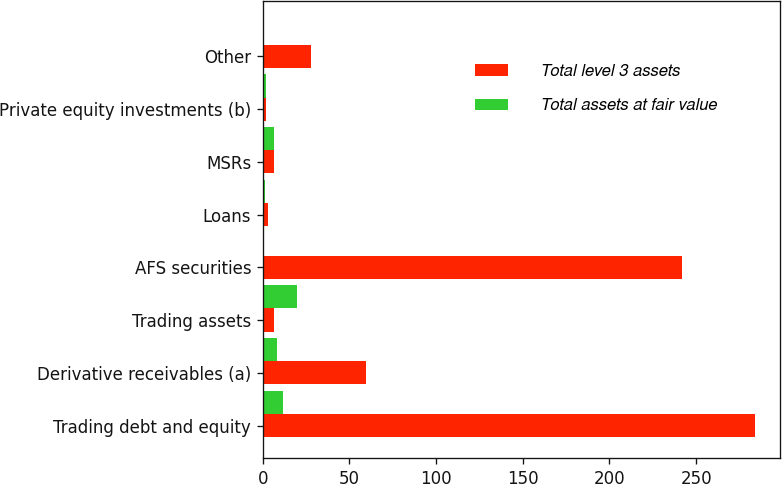<chart> <loc_0><loc_0><loc_500><loc_500><stacked_bar_chart><ecel><fcel>Trading debt and equity<fcel>Derivative receivables (a)<fcel>Trading assets<fcel>AFS securities<fcel>Loans<fcel>MSRs<fcel>Private equity investments (b)<fcel>Other<nl><fcel>Total level 3 assets<fcel>284.1<fcel>59.7<fcel>6.6<fcel>241.8<fcel>2.9<fcel>6.6<fcel>1.9<fcel>28<nl><fcel>Total assets at fair value<fcel>11.9<fcel>7.9<fcel>19.8<fcel>0.8<fcel>1.5<fcel>6.6<fcel>1.7<fcel>0.8<nl></chart> 